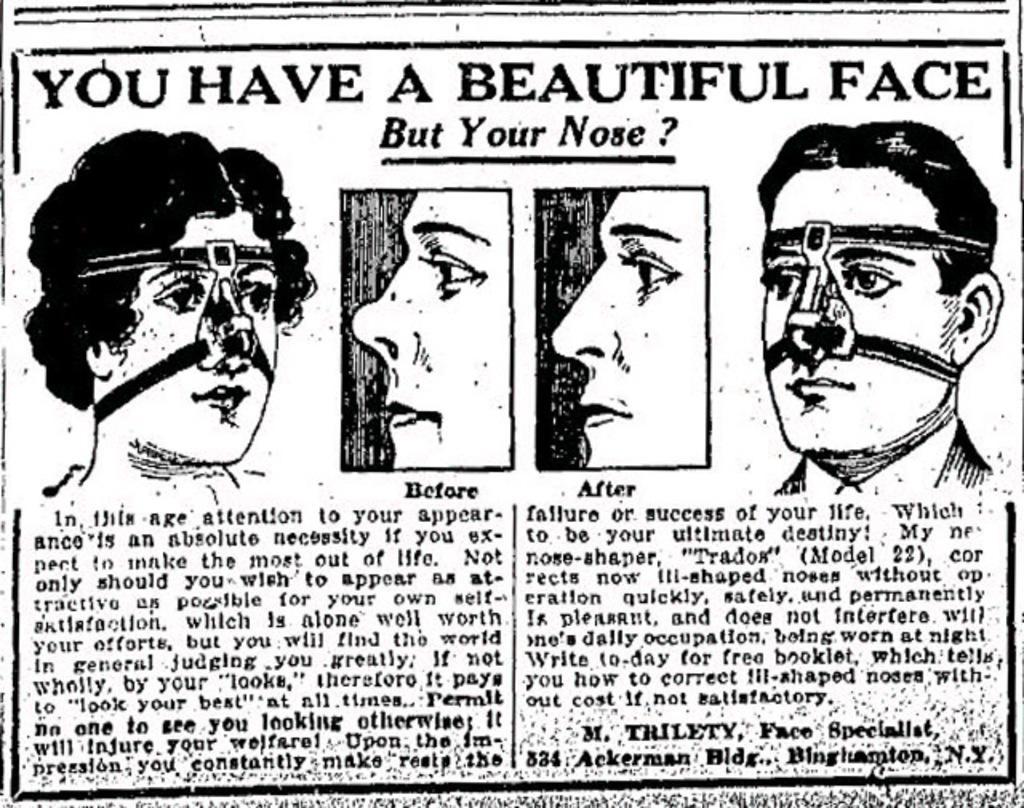Describe this image in one or two sentences. In the image there is an article with images of faces and something written on it. 